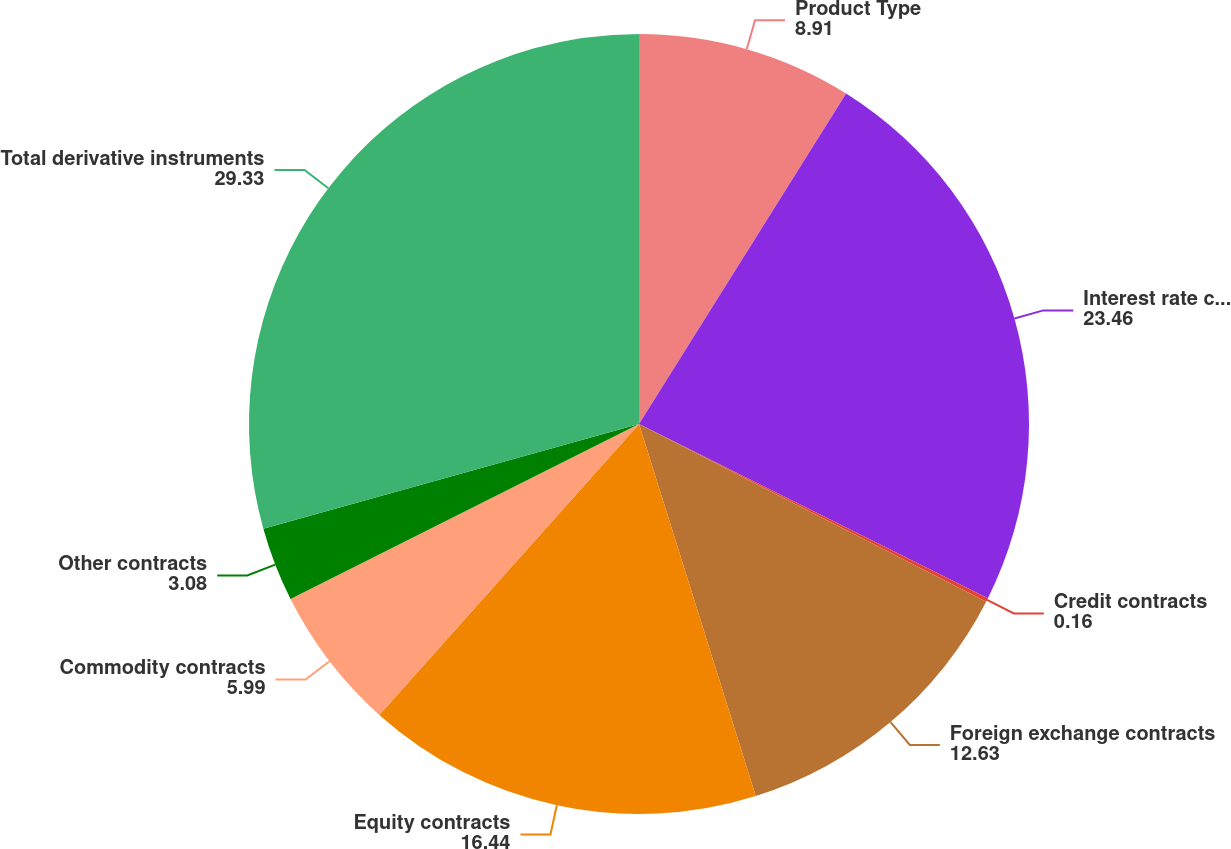Convert chart. <chart><loc_0><loc_0><loc_500><loc_500><pie_chart><fcel>Product Type<fcel>Interest rate contracts<fcel>Credit contracts<fcel>Foreign exchange contracts<fcel>Equity contracts<fcel>Commodity contracts<fcel>Other contracts<fcel>Total derivative instruments<nl><fcel>8.91%<fcel>23.46%<fcel>0.16%<fcel>12.63%<fcel>16.44%<fcel>5.99%<fcel>3.08%<fcel>29.33%<nl></chart> 